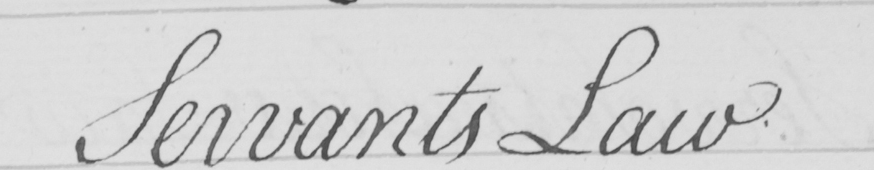What text is written in this handwritten line? Servants Law 